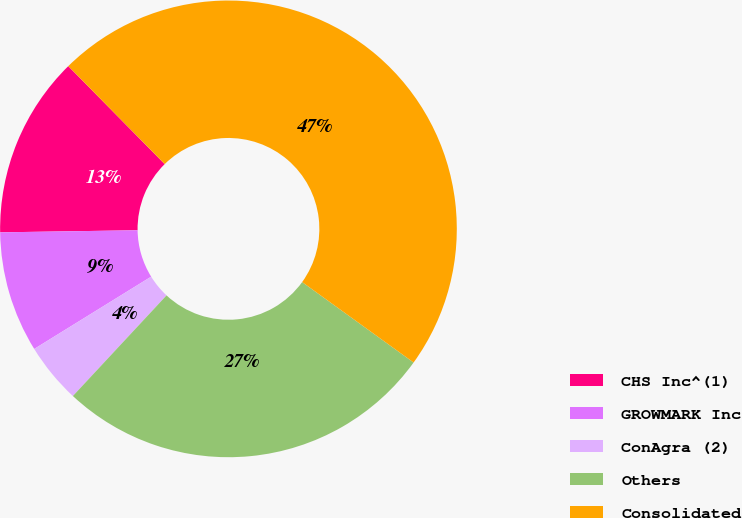Convert chart to OTSL. <chart><loc_0><loc_0><loc_500><loc_500><pie_chart><fcel>CHS Inc^(1)<fcel>GROWMARK Inc<fcel>ConAgra (2)<fcel>Others<fcel>Consolidated<nl><fcel>12.87%<fcel>8.57%<fcel>4.26%<fcel>26.98%<fcel>47.33%<nl></chart> 